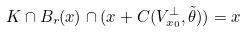Convert formula to latex. <formula><loc_0><loc_0><loc_500><loc_500>K \cap B _ { r } ( x ) \cap ( x + C ( V _ { x _ { 0 } } ^ { \bot } , \tilde { \theta } ) ) = x</formula> 